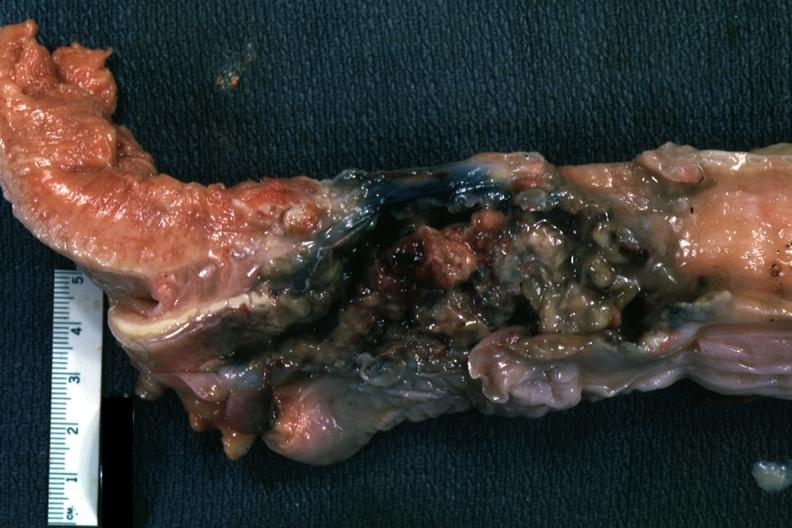s oral present?
Answer the question using a single word or phrase. Yes 